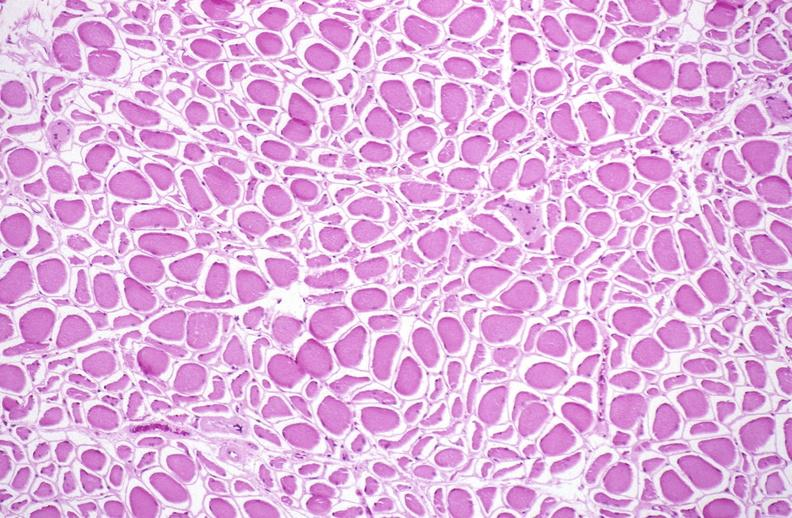does this image show skeletal muscle atrophy?
Answer the question using a single word or phrase. Yes 